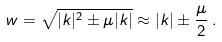Convert formula to latex. <formula><loc_0><loc_0><loc_500><loc_500>w = \sqrt { | { k } | ^ { 2 } \pm \mu | { k } | } \approx | { k } | \pm \frac { \mu } 2 \, .</formula> 